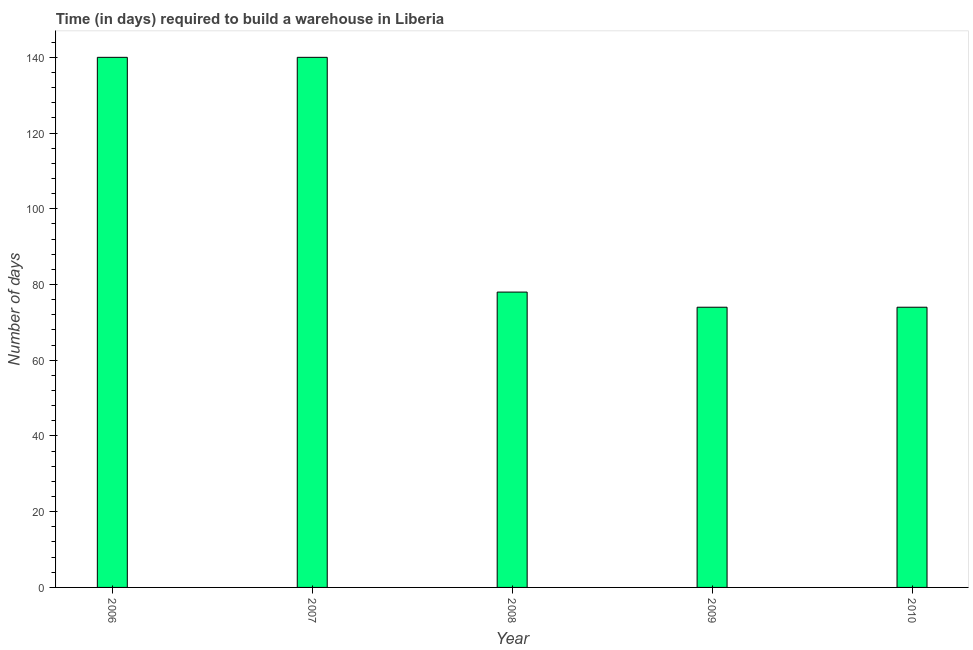Does the graph contain grids?
Your response must be concise. No. What is the title of the graph?
Your answer should be very brief. Time (in days) required to build a warehouse in Liberia. What is the label or title of the Y-axis?
Make the answer very short. Number of days. What is the time required to build a warehouse in 2009?
Ensure brevity in your answer.  74. Across all years, what is the maximum time required to build a warehouse?
Keep it short and to the point. 140. In which year was the time required to build a warehouse maximum?
Offer a terse response. 2006. What is the sum of the time required to build a warehouse?
Offer a terse response. 506. What is the difference between the time required to build a warehouse in 2006 and 2008?
Offer a terse response. 62. What is the average time required to build a warehouse per year?
Provide a succinct answer. 101. What is the median time required to build a warehouse?
Offer a terse response. 78. In how many years, is the time required to build a warehouse greater than 64 days?
Give a very brief answer. 5. What is the ratio of the time required to build a warehouse in 2007 to that in 2010?
Make the answer very short. 1.89. Is the difference between the time required to build a warehouse in 2008 and 2010 greater than the difference between any two years?
Ensure brevity in your answer.  No. What is the difference between the highest and the second highest time required to build a warehouse?
Give a very brief answer. 0. How many bars are there?
Provide a short and direct response. 5. What is the difference between two consecutive major ticks on the Y-axis?
Provide a succinct answer. 20. What is the Number of days in 2006?
Ensure brevity in your answer.  140. What is the Number of days of 2007?
Give a very brief answer. 140. What is the Number of days in 2008?
Your answer should be compact. 78. What is the Number of days of 2009?
Provide a short and direct response. 74. What is the difference between the Number of days in 2006 and 2009?
Provide a succinct answer. 66. What is the difference between the Number of days in 2007 and 2008?
Provide a short and direct response. 62. What is the difference between the Number of days in 2007 and 2010?
Offer a terse response. 66. What is the difference between the Number of days in 2008 and 2009?
Your response must be concise. 4. What is the difference between the Number of days in 2008 and 2010?
Offer a very short reply. 4. What is the difference between the Number of days in 2009 and 2010?
Give a very brief answer. 0. What is the ratio of the Number of days in 2006 to that in 2007?
Offer a terse response. 1. What is the ratio of the Number of days in 2006 to that in 2008?
Provide a short and direct response. 1.79. What is the ratio of the Number of days in 2006 to that in 2009?
Ensure brevity in your answer.  1.89. What is the ratio of the Number of days in 2006 to that in 2010?
Your response must be concise. 1.89. What is the ratio of the Number of days in 2007 to that in 2008?
Offer a terse response. 1.79. What is the ratio of the Number of days in 2007 to that in 2009?
Your answer should be compact. 1.89. What is the ratio of the Number of days in 2007 to that in 2010?
Offer a very short reply. 1.89. What is the ratio of the Number of days in 2008 to that in 2009?
Your answer should be compact. 1.05. What is the ratio of the Number of days in 2008 to that in 2010?
Provide a short and direct response. 1.05. 